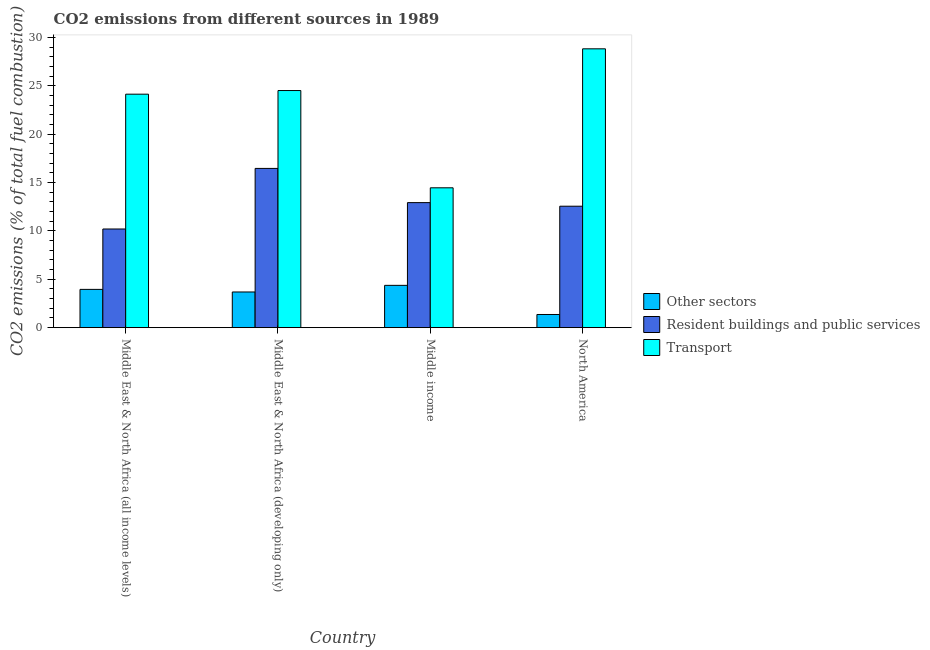Are the number of bars on each tick of the X-axis equal?
Keep it short and to the point. Yes. What is the percentage of co2 emissions from other sectors in North America?
Provide a short and direct response. 1.36. Across all countries, what is the maximum percentage of co2 emissions from transport?
Give a very brief answer. 28.83. Across all countries, what is the minimum percentage of co2 emissions from transport?
Offer a terse response. 14.46. What is the total percentage of co2 emissions from transport in the graph?
Ensure brevity in your answer.  91.96. What is the difference between the percentage of co2 emissions from resident buildings and public services in Middle East & North Africa (all income levels) and that in Middle East & North Africa (developing only)?
Provide a short and direct response. -6.26. What is the difference between the percentage of co2 emissions from other sectors in Middle income and the percentage of co2 emissions from resident buildings and public services in North America?
Keep it short and to the point. -8.18. What is the average percentage of co2 emissions from transport per country?
Provide a succinct answer. 22.99. What is the difference between the percentage of co2 emissions from other sectors and percentage of co2 emissions from resident buildings and public services in North America?
Keep it short and to the point. -11.2. What is the ratio of the percentage of co2 emissions from transport in Middle East & North Africa (all income levels) to that in Middle East & North Africa (developing only)?
Provide a succinct answer. 0.98. Is the difference between the percentage of co2 emissions from transport in Middle East & North Africa (developing only) and North America greater than the difference between the percentage of co2 emissions from other sectors in Middle East & North Africa (developing only) and North America?
Provide a short and direct response. No. What is the difference between the highest and the second highest percentage of co2 emissions from other sectors?
Your answer should be compact. 0.42. What is the difference between the highest and the lowest percentage of co2 emissions from resident buildings and public services?
Ensure brevity in your answer.  6.26. Is the sum of the percentage of co2 emissions from resident buildings and public services in Middle East & North Africa (developing only) and Middle income greater than the maximum percentage of co2 emissions from other sectors across all countries?
Offer a very short reply. Yes. What does the 1st bar from the left in Middle income represents?
Provide a short and direct response. Other sectors. What does the 1st bar from the right in Middle income represents?
Your answer should be compact. Transport. Is it the case that in every country, the sum of the percentage of co2 emissions from other sectors and percentage of co2 emissions from resident buildings and public services is greater than the percentage of co2 emissions from transport?
Ensure brevity in your answer.  No. How many bars are there?
Your answer should be very brief. 12. Are all the bars in the graph horizontal?
Make the answer very short. No. What is the difference between two consecutive major ticks on the Y-axis?
Provide a succinct answer. 5. Does the graph contain any zero values?
Keep it short and to the point. No. How are the legend labels stacked?
Give a very brief answer. Vertical. What is the title of the graph?
Provide a short and direct response. CO2 emissions from different sources in 1989. What is the label or title of the X-axis?
Make the answer very short. Country. What is the label or title of the Y-axis?
Provide a succinct answer. CO2 emissions (% of total fuel combustion). What is the CO2 emissions (% of total fuel combustion) in Other sectors in Middle East & North Africa (all income levels)?
Your response must be concise. 3.96. What is the CO2 emissions (% of total fuel combustion) in Resident buildings and public services in Middle East & North Africa (all income levels)?
Provide a short and direct response. 10.2. What is the CO2 emissions (% of total fuel combustion) of Transport in Middle East & North Africa (all income levels)?
Your response must be concise. 24.14. What is the CO2 emissions (% of total fuel combustion) in Other sectors in Middle East & North Africa (developing only)?
Your answer should be very brief. 3.69. What is the CO2 emissions (% of total fuel combustion) of Resident buildings and public services in Middle East & North Africa (developing only)?
Keep it short and to the point. 16.47. What is the CO2 emissions (% of total fuel combustion) of Transport in Middle East & North Africa (developing only)?
Make the answer very short. 24.52. What is the CO2 emissions (% of total fuel combustion) in Other sectors in Middle income?
Make the answer very short. 4.38. What is the CO2 emissions (% of total fuel combustion) in Resident buildings and public services in Middle income?
Make the answer very short. 12.93. What is the CO2 emissions (% of total fuel combustion) of Transport in Middle income?
Give a very brief answer. 14.46. What is the CO2 emissions (% of total fuel combustion) of Other sectors in North America?
Offer a terse response. 1.36. What is the CO2 emissions (% of total fuel combustion) in Resident buildings and public services in North America?
Your response must be concise. 12.56. What is the CO2 emissions (% of total fuel combustion) of Transport in North America?
Keep it short and to the point. 28.83. Across all countries, what is the maximum CO2 emissions (% of total fuel combustion) of Other sectors?
Provide a succinct answer. 4.38. Across all countries, what is the maximum CO2 emissions (% of total fuel combustion) in Resident buildings and public services?
Ensure brevity in your answer.  16.47. Across all countries, what is the maximum CO2 emissions (% of total fuel combustion) in Transport?
Offer a terse response. 28.83. Across all countries, what is the minimum CO2 emissions (% of total fuel combustion) of Other sectors?
Offer a very short reply. 1.36. Across all countries, what is the minimum CO2 emissions (% of total fuel combustion) of Resident buildings and public services?
Your response must be concise. 10.2. Across all countries, what is the minimum CO2 emissions (% of total fuel combustion) of Transport?
Your response must be concise. 14.46. What is the total CO2 emissions (% of total fuel combustion) of Other sectors in the graph?
Provide a succinct answer. 13.39. What is the total CO2 emissions (% of total fuel combustion) in Resident buildings and public services in the graph?
Make the answer very short. 52.16. What is the total CO2 emissions (% of total fuel combustion) in Transport in the graph?
Give a very brief answer. 91.96. What is the difference between the CO2 emissions (% of total fuel combustion) in Other sectors in Middle East & North Africa (all income levels) and that in Middle East & North Africa (developing only)?
Provide a short and direct response. 0.27. What is the difference between the CO2 emissions (% of total fuel combustion) in Resident buildings and public services in Middle East & North Africa (all income levels) and that in Middle East & North Africa (developing only)?
Provide a succinct answer. -6.26. What is the difference between the CO2 emissions (% of total fuel combustion) in Transport in Middle East & North Africa (all income levels) and that in Middle East & North Africa (developing only)?
Keep it short and to the point. -0.38. What is the difference between the CO2 emissions (% of total fuel combustion) of Other sectors in Middle East & North Africa (all income levels) and that in Middle income?
Offer a terse response. -0.42. What is the difference between the CO2 emissions (% of total fuel combustion) in Resident buildings and public services in Middle East & North Africa (all income levels) and that in Middle income?
Keep it short and to the point. -2.73. What is the difference between the CO2 emissions (% of total fuel combustion) of Transport in Middle East & North Africa (all income levels) and that in Middle income?
Your answer should be compact. 9.68. What is the difference between the CO2 emissions (% of total fuel combustion) of Other sectors in Middle East & North Africa (all income levels) and that in North America?
Provide a succinct answer. 2.6. What is the difference between the CO2 emissions (% of total fuel combustion) in Resident buildings and public services in Middle East & North Africa (all income levels) and that in North America?
Your response must be concise. -2.36. What is the difference between the CO2 emissions (% of total fuel combustion) in Transport in Middle East & North Africa (all income levels) and that in North America?
Your answer should be very brief. -4.69. What is the difference between the CO2 emissions (% of total fuel combustion) of Other sectors in Middle East & North Africa (developing only) and that in Middle income?
Make the answer very short. -0.69. What is the difference between the CO2 emissions (% of total fuel combustion) in Resident buildings and public services in Middle East & North Africa (developing only) and that in Middle income?
Give a very brief answer. 3.54. What is the difference between the CO2 emissions (% of total fuel combustion) in Transport in Middle East & North Africa (developing only) and that in Middle income?
Provide a short and direct response. 10.06. What is the difference between the CO2 emissions (% of total fuel combustion) of Other sectors in Middle East & North Africa (developing only) and that in North America?
Provide a succinct answer. 2.33. What is the difference between the CO2 emissions (% of total fuel combustion) of Resident buildings and public services in Middle East & North Africa (developing only) and that in North America?
Your answer should be very brief. 3.91. What is the difference between the CO2 emissions (% of total fuel combustion) in Transport in Middle East & North Africa (developing only) and that in North America?
Offer a terse response. -4.31. What is the difference between the CO2 emissions (% of total fuel combustion) of Other sectors in Middle income and that in North America?
Offer a terse response. 3.01. What is the difference between the CO2 emissions (% of total fuel combustion) of Resident buildings and public services in Middle income and that in North America?
Ensure brevity in your answer.  0.37. What is the difference between the CO2 emissions (% of total fuel combustion) in Transport in Middle income and that in North America?
Offer a terse response. -14.37. What is the difference between the CO2 emissions (% of total fuel combustion) of Other sectors in Middle East & North Africa (all income levels) and the CO2 emissions (% of total fuel combustion) of Resident buildings and public services in Middle East & North Africa (developing only)?
Keep it short and to the point. -12.51. What is the difference between the CO2 emissions (% of total fuel combustion) of Other sectors in Middle East & North Africa (all income levels) and the CO2 emissions (% of total fuel combustion) of Transport in Middle East & North Africa (developing only)?
Provide a short and direct response. -20.56. What is the difference between the CO2 emissions (% of total fuel combustion) of Resident buildings and public services in Middle East & North Africa (all income levels) and the CO2 emissions (% of total fuel combustion) of Transport in Middle East & North Africa (developing only)?
Your answer should be compact. -14.32. What is the difference between the CO2 emissions (% of total fuel combustion) in Other sectors in Middle East & North Africa (all income levels) and the CO2 emissions (% of total fuel combustion) in Resident buildings and public services in Middle income?
Offer a terse response. -8.97. What is the difference between the CO2 emissions (% of total fuel combustion) of Other sectors in Middle East & North Africa (all income levels) and the CO2 emissions (% of total fuel combustion) of Transport in Middle income?
Provide a short and direct response. -10.5. What is the difference between the CO2 emissions (% of total fuel combustion) in Resident buildings and public services in Middle East & North Africa (all income levels) and the CO2 emissions (% of total fuel combustion) in Transport in Middle income?
Give a very brief answer. -4.26. What is the difference between the CO2 emissions (% of total fuel combustion) in Other sectors in Middle East & North Africa (all income levels) and the CO2 emissions (% of total fuel combustion) in Resident buildings and public services in North America?
Ensure brevity in your answer.  -8.6. What is the difference between the CO2 emissions (% of total fuel combustion) of Other sectors in Middle East & North Africa (all income levels) and the CO2 emissions (% of total fuel combustion) of Transport in North America?
Offer a very short reply. -24.87. What is the difference between the CO2 emissions (% of total fuel combustion) in Resident buildings and public services in Middle East & North Africa (all income levels) and the CO2 emissions (% of total fuel combustion) in Transport in North America?
Provide a short and direct response. -18.63. What is the difference between the CO2 emissions (% of total fuel combustion) of Other sectors in Middle East & North Africa (developing only) and the CO2 emissions (% of total fuel combustion) of Resident buildings and public services in Middle income?
Provide a short and direct response. -9.24. What is the difference between the CO2 emissions (% of total fuel combustion) in Other sectors in Middle East & North Africa (developing only) and the CO2 emissions (% of total fuel combustion) in Transport in Middle income?
Make the answer very short. -10.77. What is the difference between the CO2 emissions (% of total fuel combustion) in Resident buildings and public services in Middle East & North Africa (developing only) and the CO2 emissions (% of total fuel combustion) in Transport in Middle income?
Make the answer very short. 2.01. What is the difference between the CO2 emissions (% of total fuel combustion) of Other sectors in Middle East & North Africa (developing only) and the CO2 emissions (% of total fuel combustion) of Resident buildings and public services in North America?
Ensure brevity in your answer.  -8.87. What is the difference between the CO2 emissions (% of total fuel combustion) of Other sectors in Middle East & North Africa (developing only) and the CO2 emissions (% of total fuel combustion) of Transport in North America?
Your answer should be compact. -25.14. What is the difference between the CO2 emissions (% of total fuel combustion) of Resident buildings and public services in Middle East & North Africa (developing only) and the CO2 emissions (% of total fuel combustion) of Transport in North America?
Provide a short and direct response. -12.37. What is the difference between the CO2 emissions (% of total fuel combustion) of Other sectors in Middle income and the CO2 emissions (% of total fuel combustion) of Resident buildings and public services in North America?
Your response must be concise. -8.18. What is the difference between the CO2 emissions (% of total fuel combustion) of Other sectors in Middle income and the CO2 emissions (% of total fuel combustion) of Transport in North America?
Ensure brevity in your answer.  -24.46. What is the difference between the CO2 emissions (% of total fuel combustion) of Resident buildings and public services in Middle income and the CO2 emissions (% of total fuel combustion) of Transport in North America?
Give a very brief answer. -15.9. What is the average CO2 emissions (% of total fuel combustion) in Other sectors per country?
Offer a very short reply. 3.35. What is the average CO2 emissions (% of total fuel combustion) in Resident buildings and public services per country?
Offer a very short reply. 13.04. What is the average CO2 emissions (% of total fuel combustion) of Transport per country?
Your answer should be compact. 22.99. What is the difference between the CO2 emissions (% of total fuel combustion) in Other sectors and CO2 emissions (% of total fuel combustion) in Resident buildings and public services in Middle East & North Africa (all income levels)?
Ensure brevity in your answer.  -6.24. What is the difference between the CO2 emissions (% of total fuel combustion) in Other sectors and CO2 emissions (% of total fuel combustion) in Transport in Middle East & North Africa (all income levels)?
Provide a succinct answer. -20.18. What is the difference between the CO2 emissions (% of total fuel combustion) in Resident buildings and public services and CO2 emissions (% of total fuel combustion) in Transport in Middle East & North Africa (all income levels)?
Your response must be concise. -13.94. What is the difference between the CO2 emissions (% of total fuel combustion) in Other sectors and CO2 emissions (% of total fuel combustion) in Resident buildings and public services in Middle East & North Africa (developing only)?
Your answer should be compact. -12.78. What is the difference between the CO2 emissions (% of total fuel combustion) in Other sectors and CO2 emissions (% of total fuel combustion) in Transport in Middle East & North Africa (developing only)?
Give a very brief answer. -20.83. What is the difference between the CO2 emissions (% of total fuel combustion) of Resident buildings and public services and CO2 emissions (% of total fuel combustion) of Transport in Middle East & North Africa (developing only)?
Offer a very short reply. -8.05. What is the difference between the CO2 emissions (% of total fuel combustion) of Other sectors and CO2 emissions (% of total fuel combustion) of Resident buildings and public services in Middle income?
Give a very brief answer. -8.55. What is the difference between the CO2 emissions (% of total fuel combustion) in Other sectors and CO2 emissions (% of total fuel combustion) in Transport in Middle income?
Give a very brief answer. -10.09. What is the difference between the CO2 emissions (% of total fuel combustion) of Resident buildings and public services and CO2 emissions (% of total fuel combustion) of Transport in Middle income?
Offer a very short reply. -1.53. What is the difference between the CO2 emissions (% of total fuel combustion) in Other sectors and CO2 emissions (% of total fuel combustion) in Resident buildings and public services in North America?
Ensure brevity in your answer.  -11.2. What is the difference between the CO2 emissions (% of total fuel combustion) of Other sectors and CO2 emissions (% of total fuel combustion) of Transport in North America?
Ensure brevity in your answer.  -27.47. What is the difference between the CO2 emissions (% of total fuel combustion) of Resident buildings and public services and CO2 emissions (% of total fuel combustion) of Transport in North America?
Provide a succinct answer. -16.27. What is the ratio of the CO2 emissions (% of total fuel combustion) of Other sectors in Middle East & North Africa (all income levels) to that in Middle East & North Africa (developing only)?
Your answer should be very brief. 1.07. What is the ratio of the CO2 emissions (% of total fuel combustion) of Resident buildings and public services in Middle East & North Africa (all income levels) to that in Middle East & North Africa (developing only)?
Your response must be concise. 0.62. What is the ratio of the CO2 emissions (% of total fuel combustion) in Transport in Middle East & North Africa (all income levels) to that in Middle East & North Africa (developing only)?
Keep it short and to the point. 0.98. What is the ratio of the CO2 emissions (% of total fuel combustion) of Other sectors in Middle East & North Africa (all income levels) to that in Middle income?
Provide a succinct answer. 0.9. What is the ratio of the CO2 emissions (% of total fuel combustion) in Resident buildings and public services in Middle East & North Africa (all income levels) to that in Middle income?
Ensure brevity in your answer.  0.79. What is the ratio of the CO2 emissions (% of total fuel combustion) of Transport in Middle East & North Africa (all income levels) to that in Middle income?
Make the answer very short. 1.67. What is the ratio of the CO2 emissions (% of total fuel combustion) of Other sectors in Middle East & North Africa (all income levels) to that in North America?
Give a very brief answer. 2.91. What is the ratio of the CO2 emissions (% of total fuel combustion) in Resident buildings and public services in Middle East & North Africa (all income levels) to that in North America?
Keep it short and to the point. 0.81. What is the ratio of the CO2 emissions (% of total fuel combustion) in Transport in Middle East & North Africa (all income levels) to that in North America?
Provide a short and direct response. 0.84. What is the ratio of the CO2 emissions (% of total fuel combustion) of Other sectors in Middle East & North Africa (developing only) to that in Middle income?
Your answer should be compact. 0.84. What is the ratio of the CO2 emissions (% of total fuel combustion) in Resident buildings and public services in Middle East & North Africa (developing only) to that in Middle income?
Offer a terse response. 1.27. What is the ratio of the CO2 emissions (% of total fuel combustion) in Transport in Middle East & North Africa (developing only) to that in Middle income?
Ensure brevity in your answer.  1.7. What is the ratio of the CO2 emissions (% of total fuel combustion) in Other sectors in Middle East & North Africa (developing only) to that in North America?
Make the answer very short. 2.71. What is the ratio of the CO2 emissions (% of total fuel combustion) of Resident buildings and public services in Middle East & North Africa (developing only) to that in North America?
Offer a very short reply. 1.31. What is the ratio of the CO2 emissions (% of total fuel combustion) of Transport in Middle East & North Africa (developing only) to that in North America?
Offer a very short reply. 0.85. What is the ratio of the CO2 emissions (% of total fuel combustion) in Other sectors in Middle income to that in North America?
Keep it short and to the point. 3.21. What is the ratio of the CO2 emissions (% of total fuel combustion) in Resident buildings and public services in Middle income to that in North America?
Make the answer very short. 1.03. What is the ratio of the CO2 emissions (% of total fuel combustion) of Transport in Middle income to that in North America?
Make the answer very short. 0.5. What is the difference between the highest and the second highest CO2 emissions (% of total fuel combustion) of Other sectors?
Provide a short and direct response. 0.42. What is the difference between the highest and the second highest CO2 emissions (% of total fuel combustion) in Resident buildings and public services?
Your answer should be very brief. 3.54. What is the difference between the highest and the second highest CO2 emissions (% of total fuel combustion) of Transport?
Provide a short and direct response. 4.31. What is the difference between the highest and the lowest CO2 emissions (% of total fuel combustion) of Other sectors?
Your answer should be compact. 3.01. What is the difference between the highest and the lowest CO2 emissions (% of total fuel combustion) of Resident buildings and public services?
Keep it short and to the point. 6.26. What is the difference between the highest and the lowest CO2 emissions (% of total fuel combustion) in Transport?
Your answer should be very brief. 14.37. 